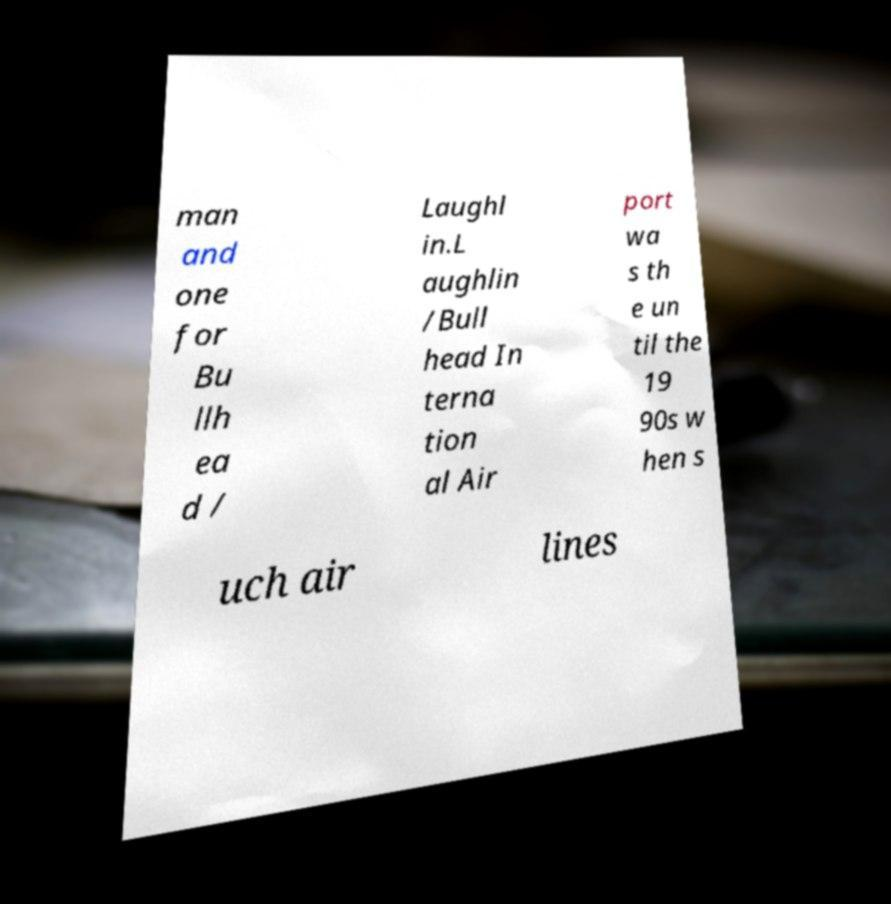Can you accurately transcribe the text from the provided image for me? man and one for Bu llh ea d / Laughl in.L aughlin /Bull head In terna tion al Air port wa s th e un til the 19 90s w hen s uch air lines 